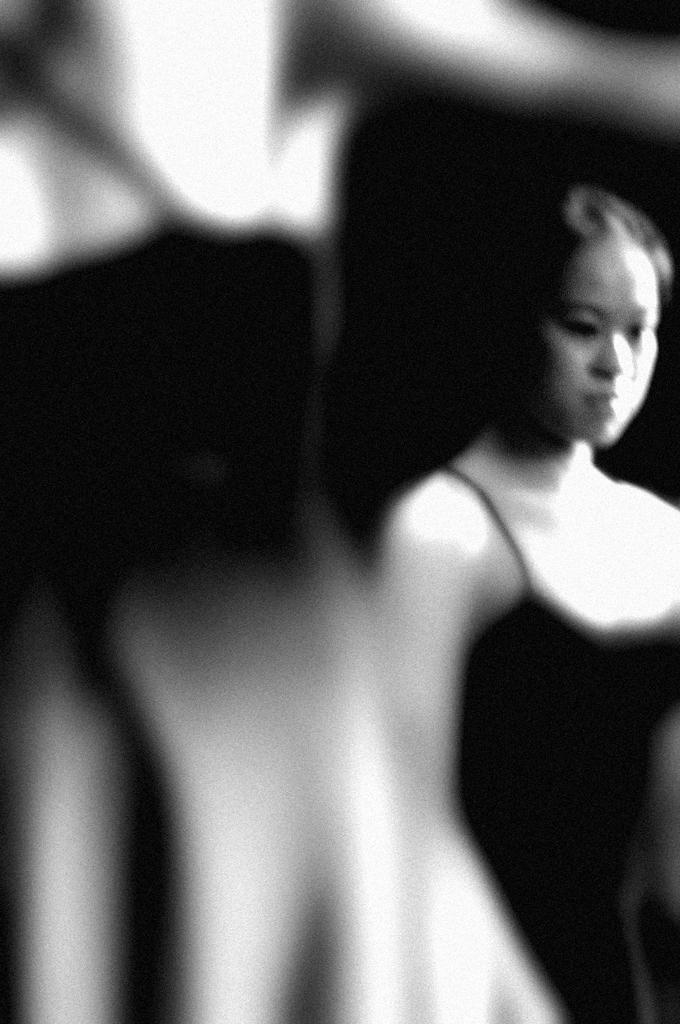How would you summarize this image in a sentence or two? This is a black and white image. To the right side of the image there is a lady with black dress. And to the left side of the image it is blurry. 